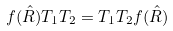<formula> <loc_0><loc_0><loc_500><loc_500>f ( \hat { R } ) T _ { 1 } T _ { 2 } = T _ { 1 } T _ { 2 } f ( \hat { R } )</formula> 